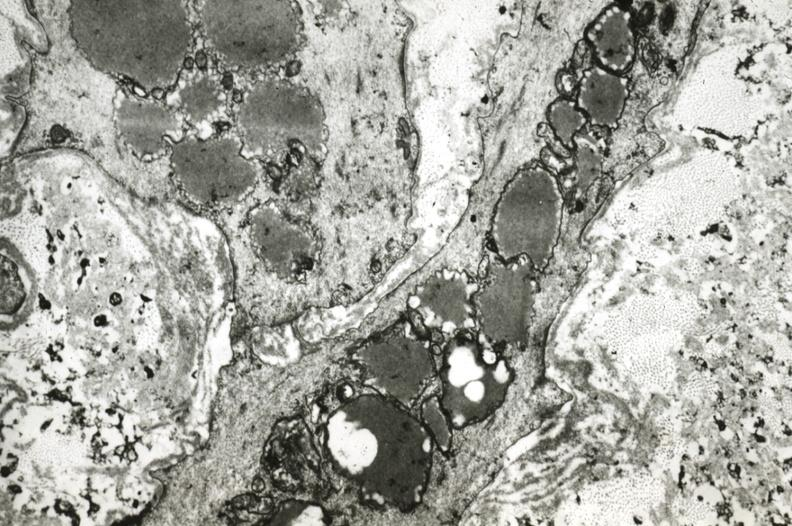what does this image show?
Answer the question using a single word or phrase. Intimal smooth muscle cells with lipid in cytoplasm and precipitated lipid in interstitial space 